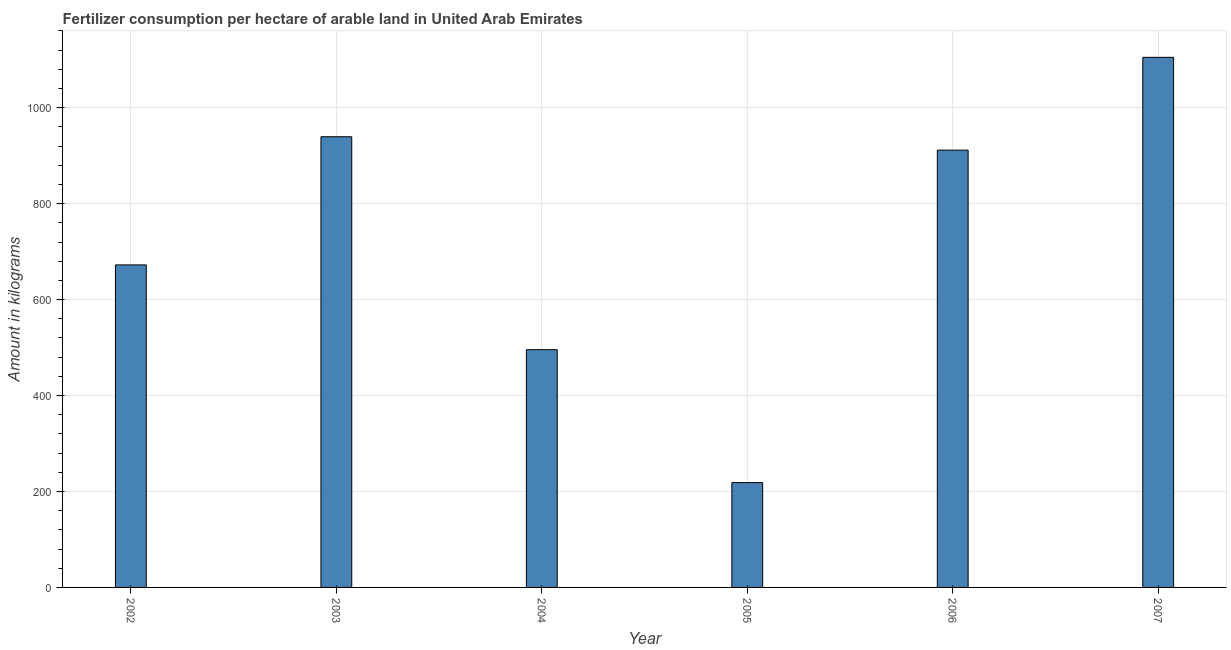Does the graph contain any zero values?
Offer a terse response. No. Does the graph contain grids?
Provide a succinct answer. Yes. What is the title of the graph?
Ensure brevity in your answer.  Fertilizer consumption per hectare of arable land in United Arab Emirates . What is the label or title of the X-axis?
Make the answer very short. Year. What is the label or title of the Y-axis?
Give a very brief answer. Amount in kilograms. What is the amount of fertilizer consumption in 2004?
Your answer should be compact. 495.56. Across all years, what is the maximum amount of fertilizer consumption?
Give a very brief answer. 1104.93. Across all years, what is the minimum amount of fertilizer consumption?
Provide a succinct answer. 218.54. What is the sum of the amount of fertilizer consumption?
Offer a terse response. 4342.14. What is the difference between the amount of fertilizer consumption in 2002 and 2004?
Provide a short and direct response. 176.71. What is the average amount of fertilizer consumption per year?
Your response must be concise. 723.69. What is the median amount of fertilizer consumption?
Provide a short and direct response. 791.86. Do a majority of the years between 2002 and 2003 (inclusive) have amount of fertilizer consumption greater than 40 kg?
Offer a very short reply. Yes. What is the ratio of the amount of fertilizer consumption in 2004 to that in 2006?
Keep it short and to the point. 0.54. What is the difference between the highest and the second highest amount of fertilizer consumption?
Provide a succinct answer. 165.56. Is the sum of the amount of fertilizer consumption in 2004 and 2007 greater than the maximum amount of fertilizer consumption across all years?
Give a very brief answer. Yes. What is the difference between the highest and the lowest amount of fertilizer consumption?
Provide a succinct answer. 886.39. In how many years, is the amount of fertilizer consumption greater than the average amount of fertilizer consumption taken over all years?
Your answer should be very brief. 3. How many bars are there?
Offer a very short reply. 6. Are all the bars in the graph horizontal?
Keep it short and to the point. No. Are the values on the major ticks of Y-axis written in scientific E-notation?
Ensure brevity in your answer.  No. What is the Amount in kilograms of 2002?
Provide a succinct answer. 672.27. What is the Amount in kilograms in 2003?
Your response must be concise. 939.38. What is the Amount in kilograms in 2004?
Provide a succinct answer. 495.56. What is the Amount in kilograms in 2005?
Provide a succinct answer. 218.54. What is the Amount in kilograms in 2006?
Provide a succinct answer. 911.46. What is the Amount in kilograms in 2007?
Your answer should be compact. 1104.93. What is the difference between the Amount in kilograms in 2002 and 2003?
Make the answer very short. -267.11. What is the difference between the Amount in kilograms in 2002 and 2004?
Offer a terse response. 176.71. What is the difference between the Amount in kilograms in 2002 and 2005?
Offer a terse response. 453.72. What is the difference between the Amount in kilograms in 2002 and 2006?
Provide a short and direct response. -239.2. What is the difference between the Amount in kilograms in 2002 and 2007?
Your answer should be very brief. -432.67. What is the difference between the Amount in kilograms in 2003 and 2004?
Make the answer very short. 443.82. What is the difference between the Amount in kilograms in 2003 and 2005?
Make the answer very short. 720.83. What is the difference between the Amount in kilograms in 2003 and 2006?
Your answer should be very brief. 27.91. What is the difference between the Amount in kilograms in 2003 and 2007?
Offer a terse response. -165.56. What is the difference between the Amount in kilograms in 2004 and 2005?
Your answer should be compact. 277.01. What is the difference between the Amount in kilograms in 2004 and 2006?
Make the answer very short. -415.91. What is the difference between the Amount in kilograms in 2004 and 2007?
Offer a very short reply. -609.38. What is the difference between the Amount in kilograms in 2005 and 2006?
Your answer should be compact. -692.92. What is the difference between the Amount in kilograms in 2005 and 2007?
Your answer should be compact. -886.39. What is the difference between the Amount in kilograms in 2006 and 2007?
Your response must be concise. -193.47. What is the ratio of the Amount in kilograms in 2002 to that in 2003?
Offer a terse response. 0.72. What is the ratio of the Amount in kilograms in 2002 to that in 2004?
Provide a succinct answer. 1.36. What is the ratio of the Amount in kilograms in 2002 to that in 2005?
Give a very brief answer. 3.08. What is the ratio of the Amount in kilograms in 2002 to that in 2006?
Make the answer very short. 0.74. What is the ratio of the Amount in kilograms in 2002 to that in 2007?
Provide a short and direct response. 0.61. What is the ratio of the Amount in kilograms in 2003 to that in 2004?
Ensure brevity in your answer.  1.9. What is the ratio of the Amount in kilograms in 2003 to that in 2005?
Make the answer very short. 4.3. What is the ratio of the Amount in kilograms in 2003 to that in 2006?
Offer a terse response. 1.03. What is the ratio of the Amount in kilograms in 2003 to that in 2007?
Provide a short and direct response. 0.85. What is the ratio of the Amount in kilograms in 2004 to that in 2005?
Offer a very short reply. 2.27. What is the ratio of the Amount in kilograms in 2004 to that in 2006?
Your answer should be compact. 0.54. What is the ratio of the Amount in kilograms in 2004 to that in 2007?
Ensure brevity in your answer.  0.45. What is the ratio of the Amount in kilograms in 2005 to that in 2006?
Your answer should be very brief. 0.24. What is the ratio of the Amount in kilograms in 2005 to that in 2007?
Your answer should be compact. 0.2. What is the ratio of the Amount in kilograms in 2006 to that in 2007?
Your response must be concise. 0.82. 